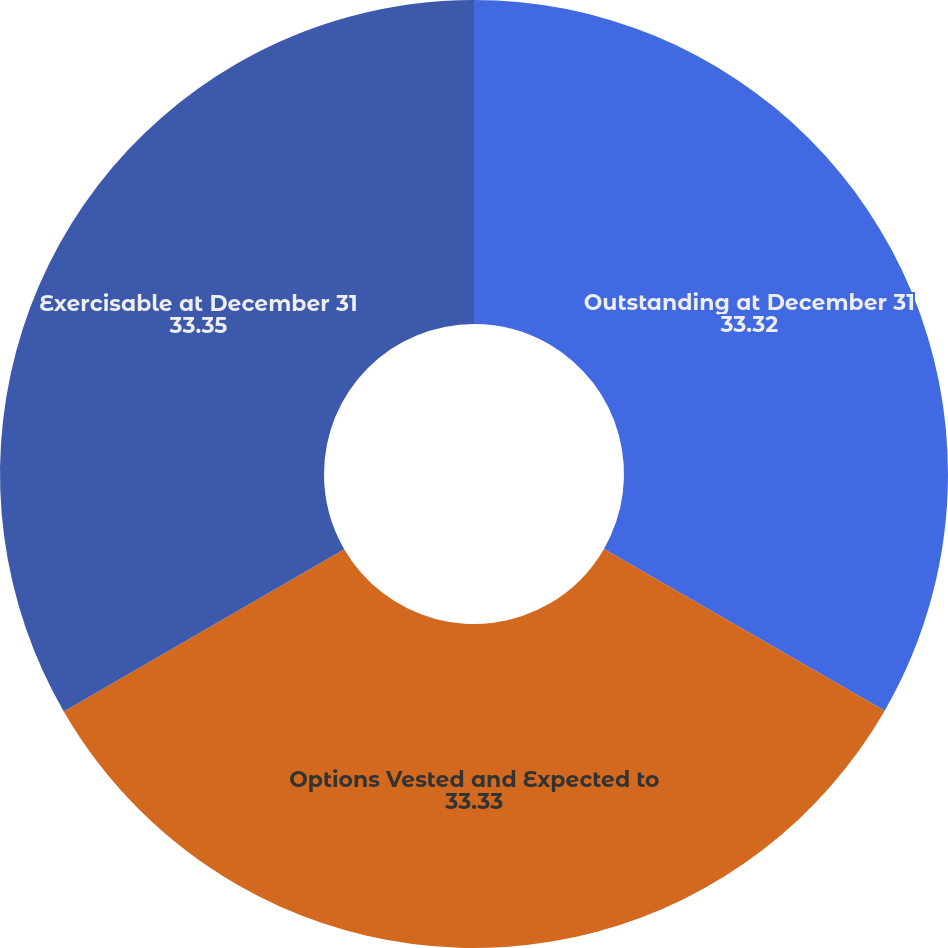Convert chart to OTSL. <chart><loc_0><loc_0><loc_500><loc_500><pie_chart><fcel>Outstanding at December 31<fcel>Options Vested and Expected to<fcel>Exercisable at December 31<nl><fcel>33.32%<fcel>33.33%<fcel>33.35%<nl></chart> 